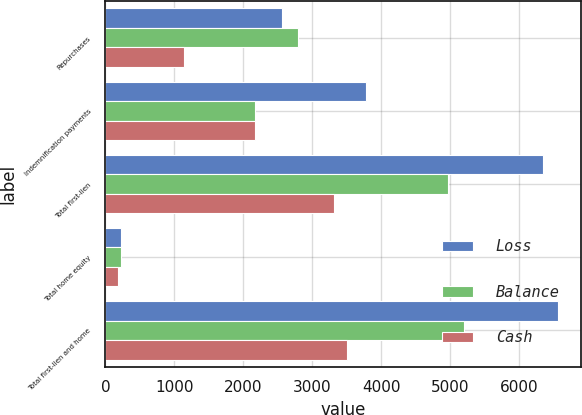<chart> <loc_0><loc_0><loc_500><loc_500><stacked_bar_chart><ecel><fcel>Repurchases<fcel>Indemnification payments<fcel>Total first-lien<fcel>Total home equity<fcel>Total first-lien and home<nl><fcel>Loss<fcel>2557<fcel>3785<fcel>6342<fcel>227<fcel>6569<nl><fcel>Balance<fcel>2799<fcel>2173<fcel>4972<fcel>232<fcel>5204<nl><fcel>Cash<fcel>1142<fcel>2173<fcel>3315<fcel>190<fcel>3505<nl></chart> 